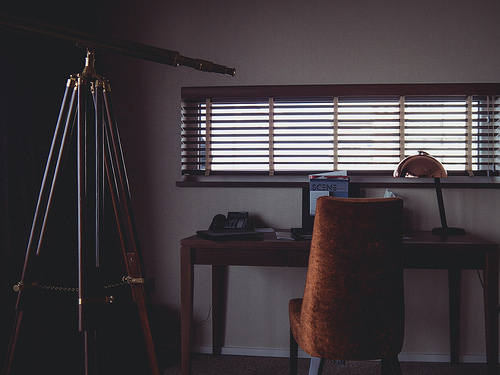<image>
Can you confirm if the desk is next to the telescope? Yes. The desk is positioned adjacent to the telescope, located nearby in the same general area. 